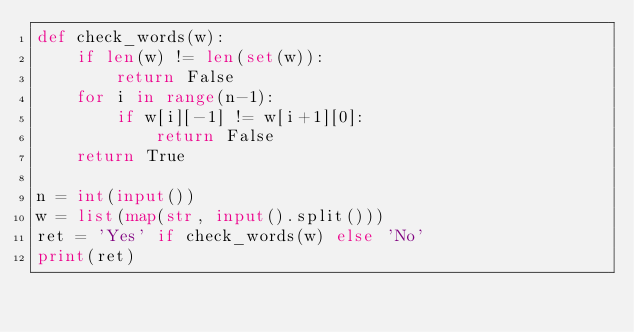Convert code to text. <code><loc_0><loc_0><loc_500><loc_500><_Python_>def check_words(w):
    if len(w) != len(set(w)):
        return False
    for i in range(n-1):
        if w[i][-1] != w[i+1][0]:
            return False
    return True

n = int(input())
w = list(map(str, input().split()))
ret = 'Yes' if check_words(w) else 'No'
print(ret)</code> 